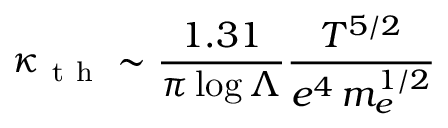Convert formula to latex. <formula><loc_0><loc_0><loc_500><loc_500>\kappa _ { t h } \sim \frac { 1 . 3 1 } { \pi \log \Lambda } \frac { T ^ { 5 / 2 } } { e ^ { 4 } \, m _ { e } ^ { 1 / 2 } }</formula> 